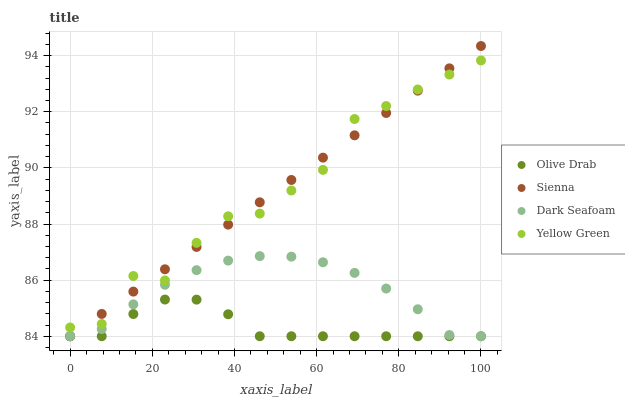Does Olive Drab have the minimum area under the curve?
Answer yes or no. Yes. Does Sienna have the maximum area under the curve?
Answer yes or no. Yes. Does Dark Seafoam have the minimum area under the curve?
Answer yes or no. No. Does Dark Seafoam have the maximum area under the curve?
Answer yes or no. No. Is Sienna the smoothest?
Answer yes or no. Yes. Is Yellow Green the roughest?
Answer yes or no. Yes. Is Dark Seafoam the smoothest?
Answer yes or no. No. Is Dark Seafoam the roughest?
Answer yes or no. No. Does Sienna have the lowest value?
Answer yes or no. Yes. Does Yellow Green have the lowest value?
Answer yes or no. No. Does Sienna have the highest value?
Answer yes or no. Yes. Does Dark Seafoam have the highest value?
Answer yes or no. No. Is Dark Seafoam less than Yellow Green?
Answer yes or no. Yes. Is Yellow Green greater than Olive Drab?
Answer yes or no. Yes. Does Dark Seafoam intersect Olive Drab?
Answer yes or no. Yes. Is Dark Seafoam less than Olive Drab?
Answer yes or no. No. Is Dark Seafoam greater than Olive Drab?
Answer yes or no. No. Does Dark Seafoam intersect Yellow Green?
Answer yes or no. No. 